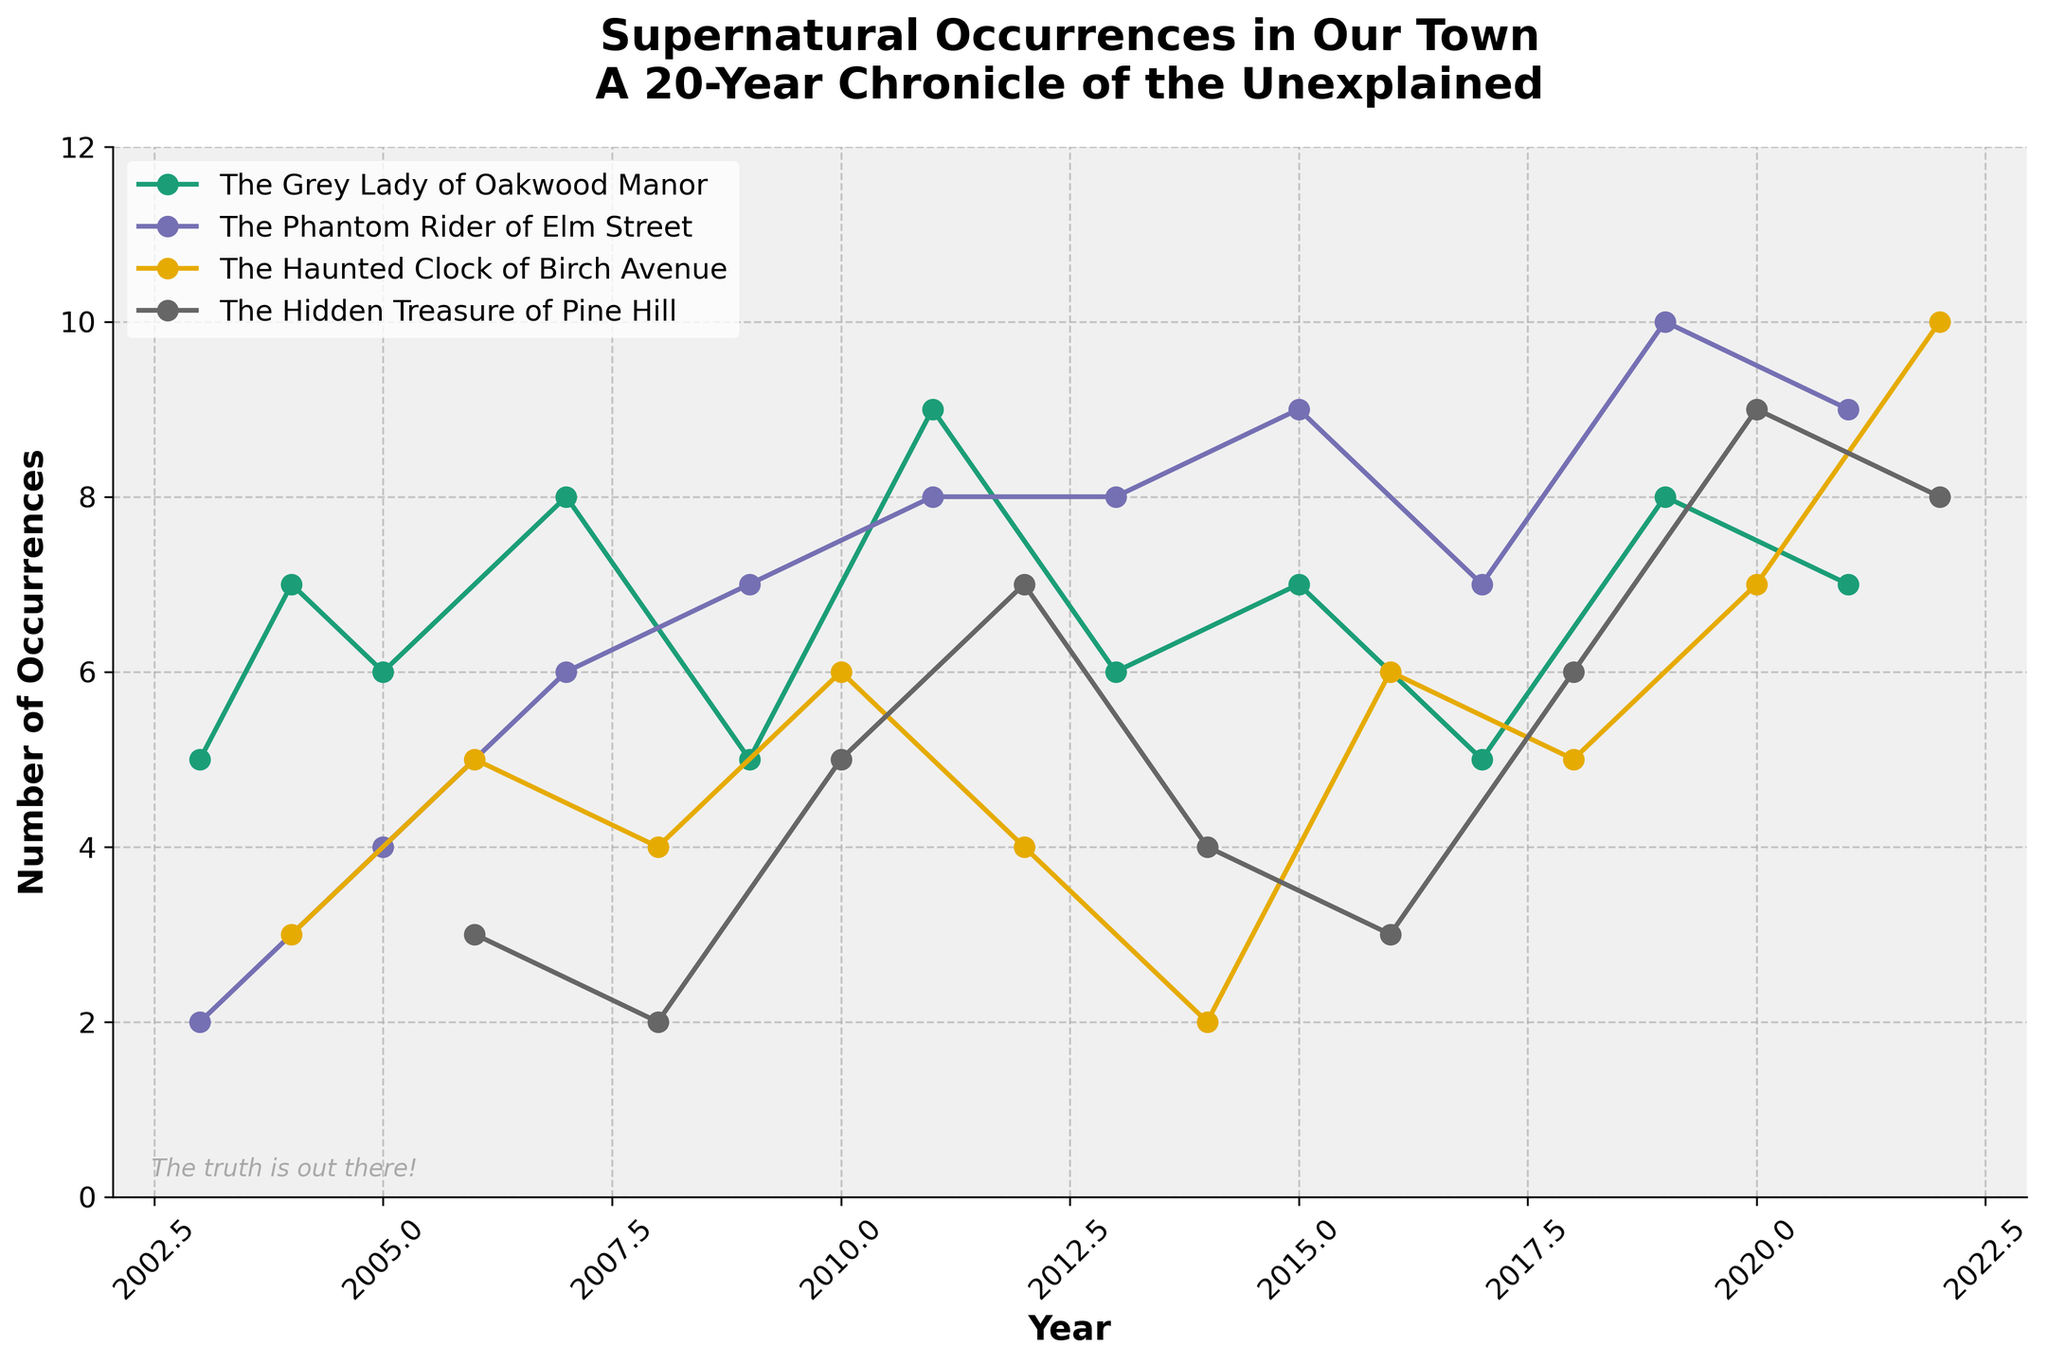What's the title of the figure? The title is displayed at the top of the plot. It reads "Supernatural Occurrences in Our Town: A 20-Year Chronicle of the Unexplained".
Answer: Supernatural Occurrences in Our Town: A 20-Year Chronicle of the Unexplained What is the range of years shown on the x-axis? The x-axis represents years. The plot begins at 2003 and ends at 2022.
Answer: 2003-2022 Which legend had the highest number of occurrences in any given year and what was the number? By inspecting all the lines, the highest peak is observed in "The Phantom Rider of Elm Street" in 2019, reaching up to 10 occurrences.
Answer: The Phantom Rider of Elm Street with 10 occurrences How many occurrences of "The Grey Lady of Oakwood Manor" were recorded in 2011? Locate the point for "The Grey Lady of Oakwood Manor" on the graph for the year 2011. The value marked is 9.
Answer: 9 What are the colors used to represent each local legend? Each line representing a local legend has a distinct color. Examine the lines and the legend box.
- "The Grey Lady of Oakwood Manor" is in blue.
- "The Phantom Rider of Elm Street" is in orange.
- "The Hidden Treasure of Pine Hill" is in green.
- "The Haunted Clock of Birch Avenue" is in red.
Answer: Blue, Orange, Green, Red Which legend had the most consistent number of occurrences throughout the years? Consistency would mean minimal fluctuation over the years. "The Haunted Clock of Birch Avenue" shows relatively steady changes compared to others.
Answer: The Haunted Clock of Birch Avenue What is the total number of occurrences for all legends in 2020? Check the year 2020 and sum all occurrences.
- "The Grey Lady of Oakwood Manor": 7
- "The Phantom Rider of Elm Street": 9
- "The Hidden Treasure of Pine Hill": 9
- "The Haunted Clock of Birch Avenue": 7
The sum is 7 + 9 + 9 + 7 = 32.
Answer: 32 Did "The Hidden Treasure of Pine Hill" ever have zero occurrences in any given year? Review the trace for "The Hidden Treasure of Pine Hill." The lowest value on the plot is 2, indicating there were no years with 0 occurrences.
Answer: No Between 2007 and 2012, which legend showed the greatest increase in occurrences? Calculate the difference in occurrences for each legend between 2007 and 2012.
- "The Grey Lady of Oakwood Manor": 9 - 8 = 1
- "The Phantom Rider of Elm Street": 8 - 6 = 2
- "The Hidden Treasure of Pine Hill": 7 - 2 = 5
- "The Haunted Clock of Birch Avenue": 4 - 5 = -1
"The Hidden Treasure of Pine Hill" showed the greatest increase of 5.
Answer: The Hidden Treasure of Pine Hill In which year did "The Phantom Rider of Elm Street" first surpass 8 occurrences? Trace "The Phantom Rider of Elm Street" line until it surpasses 8 occurrences. It first reaches 9 occurrences in 2015.
Answer: 2015 Comparing "The Grey Lady of Oakwood Manor" and "The Haunted Clock of Birch Avenue," which legend had more occurrences overall? Sum the occurrences for each legend over the years.
- "The Grey Lady of Oakwood Manor": 5+7+6+8+5+9+6+7+5+8+7 = 73
- "The Haunted Clock of Birch Avenue": 3+5+4+6+4+2+6+5+7+10 = 52
"The Grey Lady of Oakwood Manor" has more overall occurrences with 73 compared to 52.
Answer: The Grey Lady of Oakwood Manor 